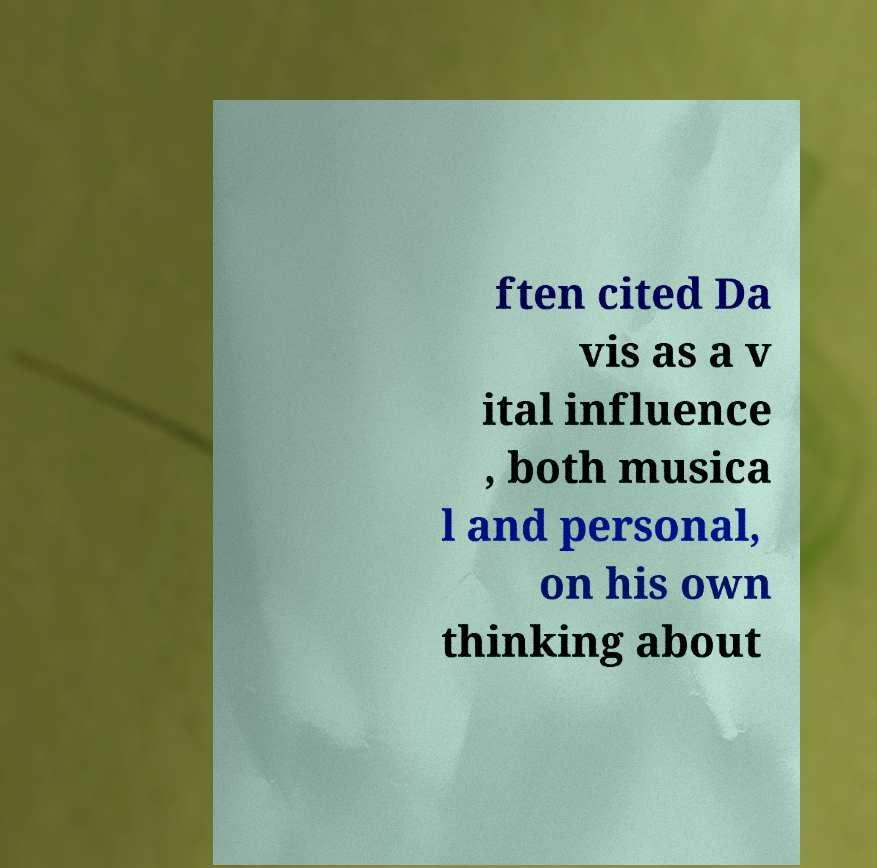There's text embedded in this image that I need extracted. Can you transcribe it verbatim? ften cited Da vis as a v ital influence , both musica l and personal, on his own thinking about 